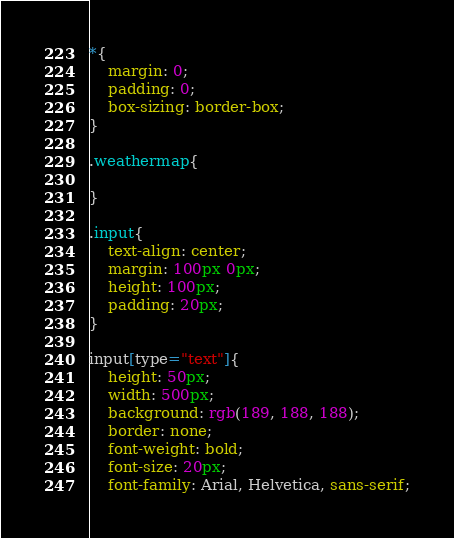<code> <loc_0><loc_0><loc_500><loc_500><_CSS_>*{
    margin: 0;
    padding: 0;
    box-sizing: border-box;
}

.weathermap{
    
}

.input{
    text-align: center;
    margin: 100px 0px;
    height: 100px;
    padding: 20px;
}

input[type="text"]{
    height: 50px;
    width: 500px;
    background: rgb(189, 188, 188);
    border: none;
    font-weight: bold;
    font-size: 20px;
    font-family: Arial, Helvetica, sans-serif;</code> 